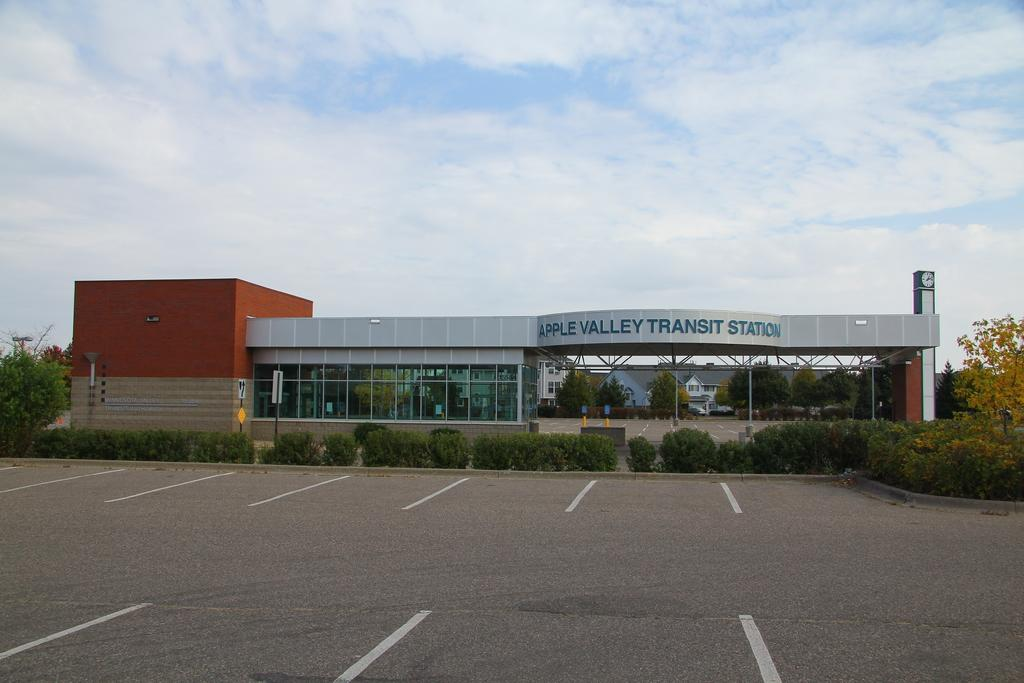<image>
Write a terse but informative summary of the picture. The parking lot of the Apple Valley Transit Station is empty. 